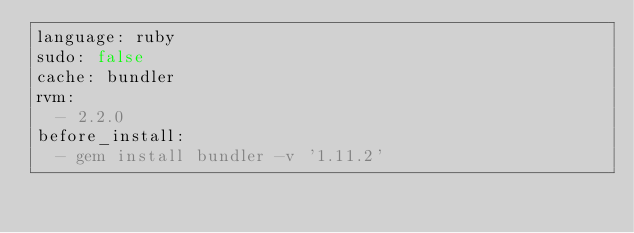Convert code to text. <code><loc_0><loc_0><loc_500><loc_500><_YAML_>language: ruby
sudo: false
cache: bundler
rvm:
  - 2.2.0
before_install:
  - gem install bundler -v '1.11.2'
</code> 